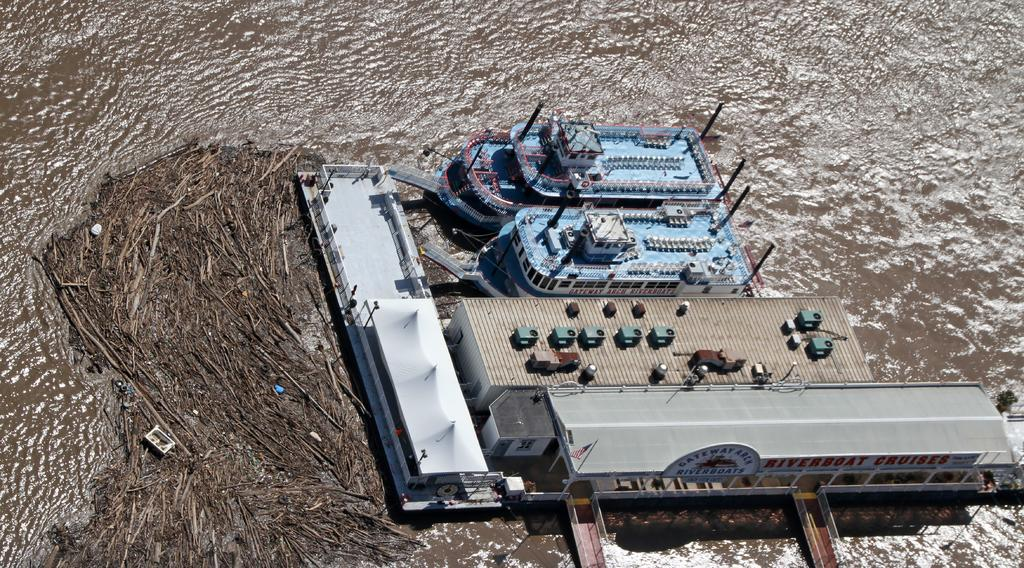What structure can be seen in the image? There is a dock in the image. What type of vehicles are present in the image? There are blue color ships in the image. How are the ships positioned in the image? The ships are floating on the water. What is the primary setting of the image? The water is visible in the image, and it is in the background. What type of songs can be heard coming from the ghost in the image? There is no ghost present in the image, so it's not possible to determine what, if any, songs might be heard. 